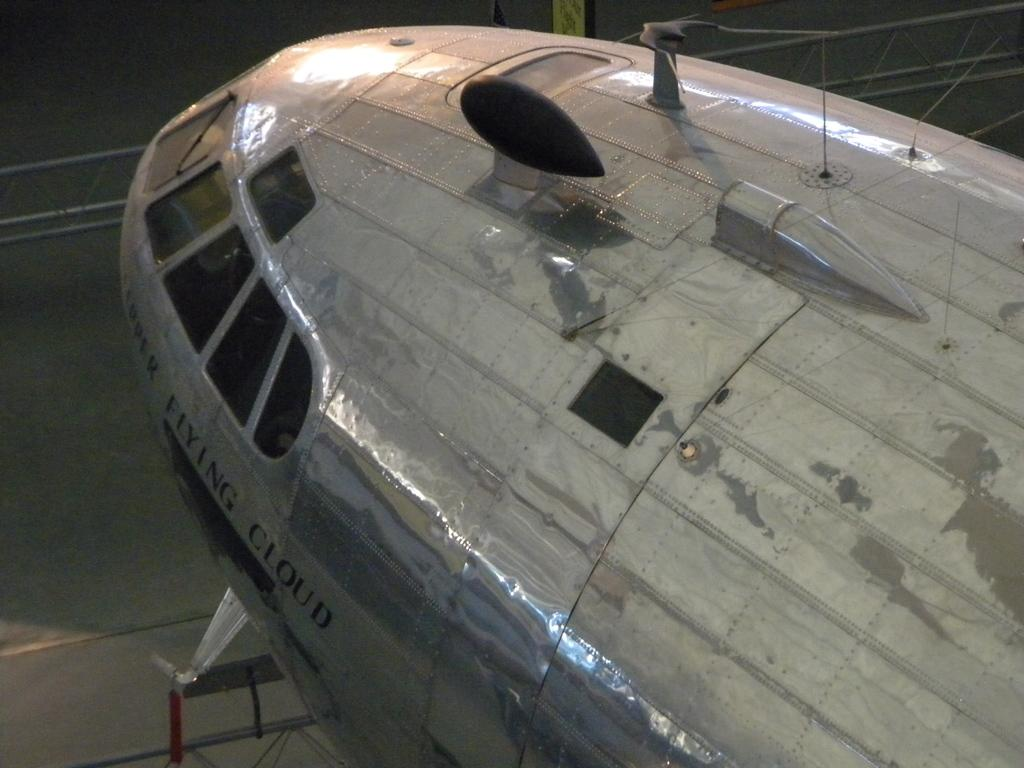<image>
Summarize the visual content of the image. An airplane has the name Flying Cloud on it under the front windshield. 